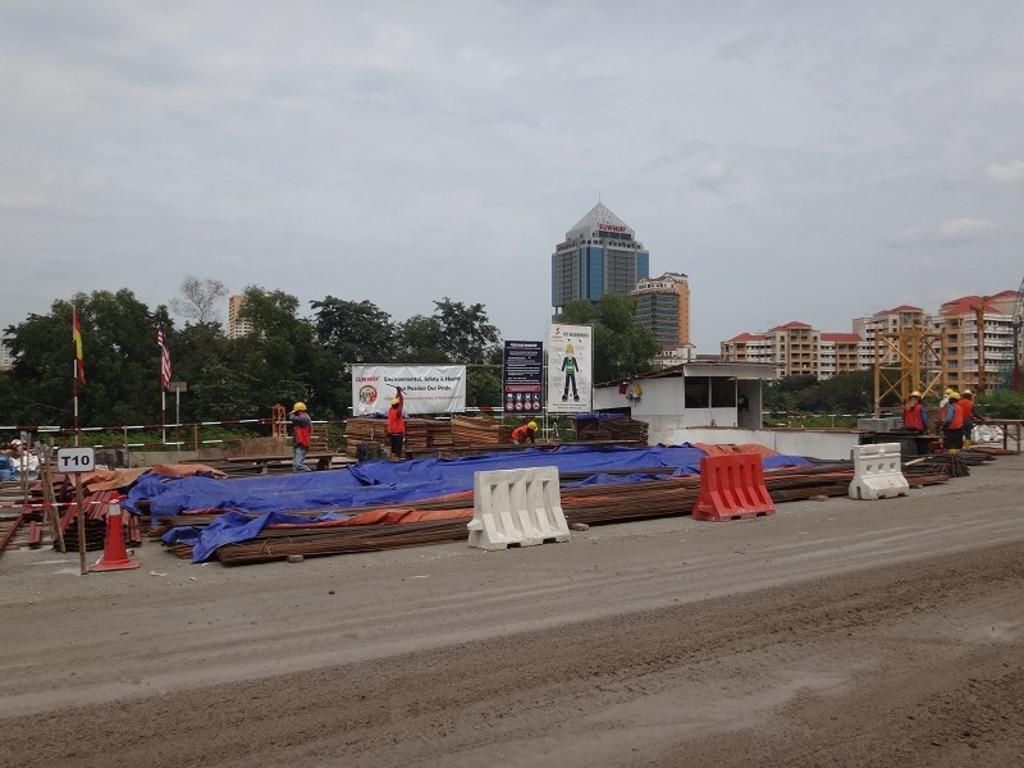Could you give a brief overview of what you see in this image? In this image, there is an outside view. There are some buildings on the right side of the image. There are some trees and flags on the left side of the image. There are rods and dividers in the middle of the image. In the background of the image, there is a sky. 